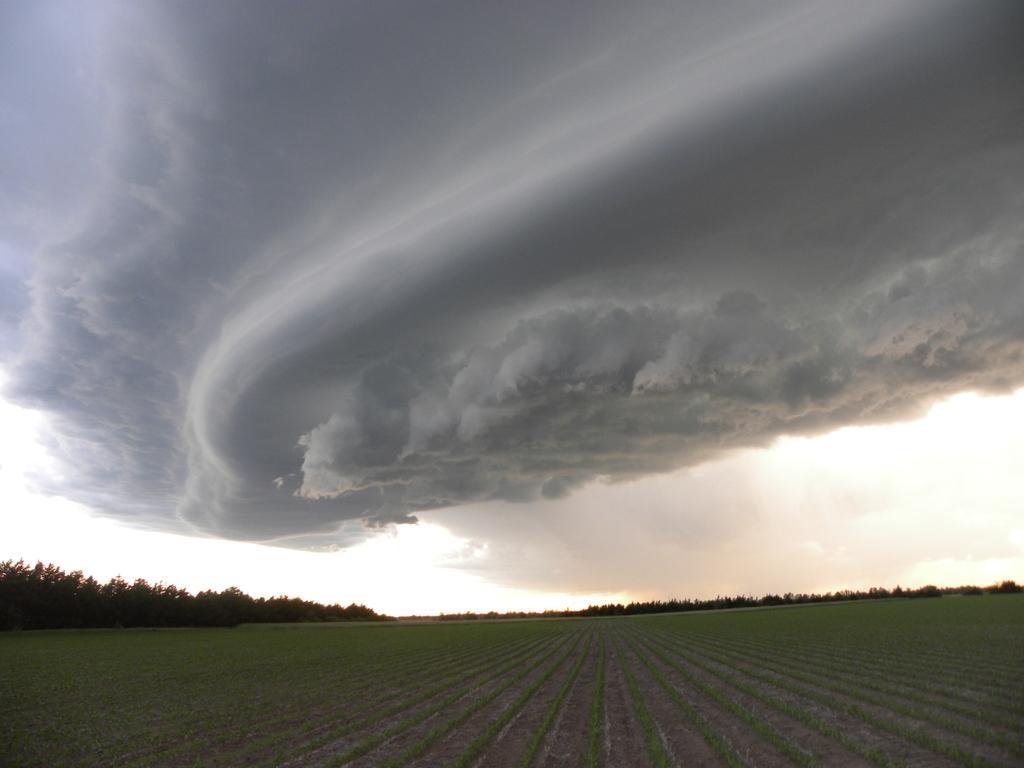How would you summarize this image in a sentence or two? In this image, there is an outside view. There are clouds in the sky. There is a field at the bottom of the image. 